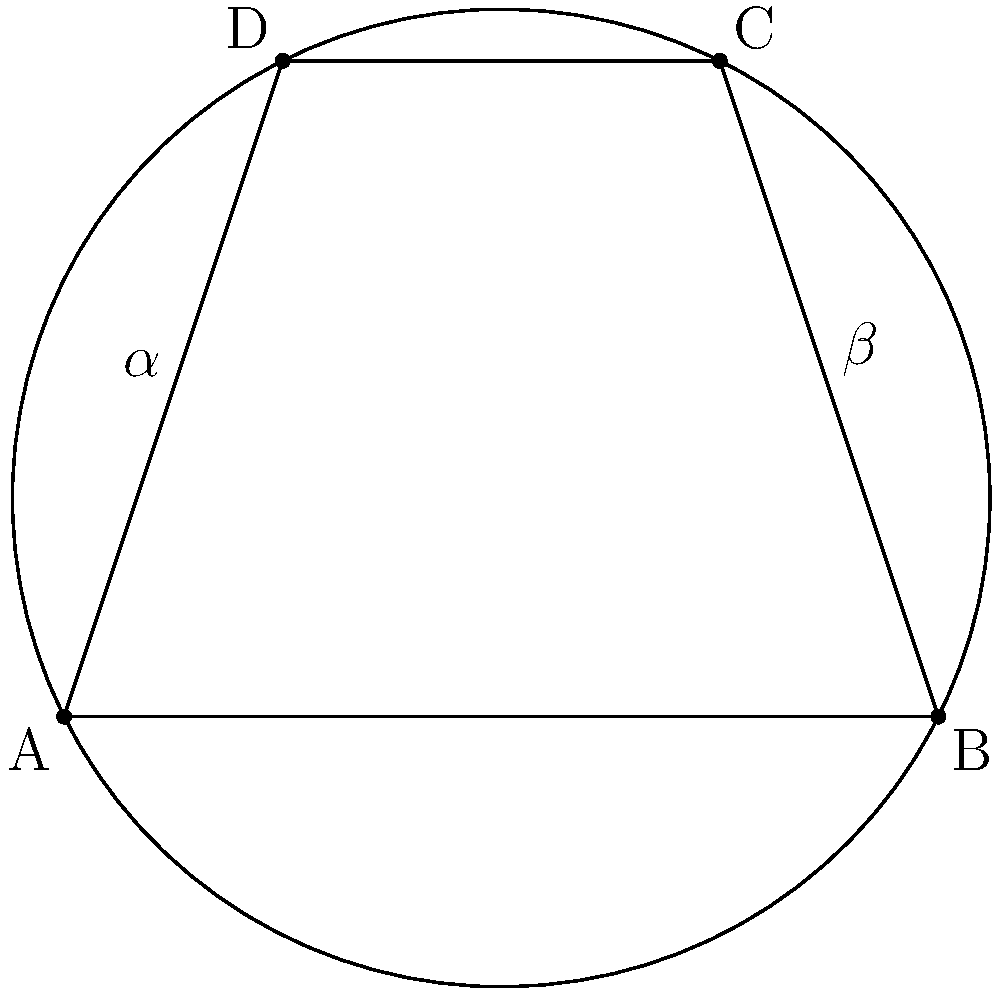In the cyclic quadrilateral ABCD shown above, angles $\alpha$ and $\beta$ are inscribed angles. If $\alpha = 40°$, what is the measure of $\beta$? Express your answer in degrees. Let's approach this step-by-step:

1) In a cyclic quadrilateral, opposite angles are supplementary. This means that $\alpha + \beta = 180°$.

2) We are given that $\alpha = 40°$.

3) To find $\beta$, we can subtract $\alpha$ from 180°:

   $\beta = 180° - \alpha$
   $\beta = 180° - 40°$
   $\beta = 140°$

4) This result can be verified by considering the properties of inscribed angles:
   - An inscribed angle is half the central angle that subtends the same arc.
   - The sum of central angles in a circle is 360°.
   - Therefore, the sum of inscribed angles in a cyclic quadrilateral is half of 360°, which is 180°.

5) Our solution satisfies this property: $40° + 140° = 180°$

Thus, the measure of angle $\beta$ is 140°.
Answer: 140° 